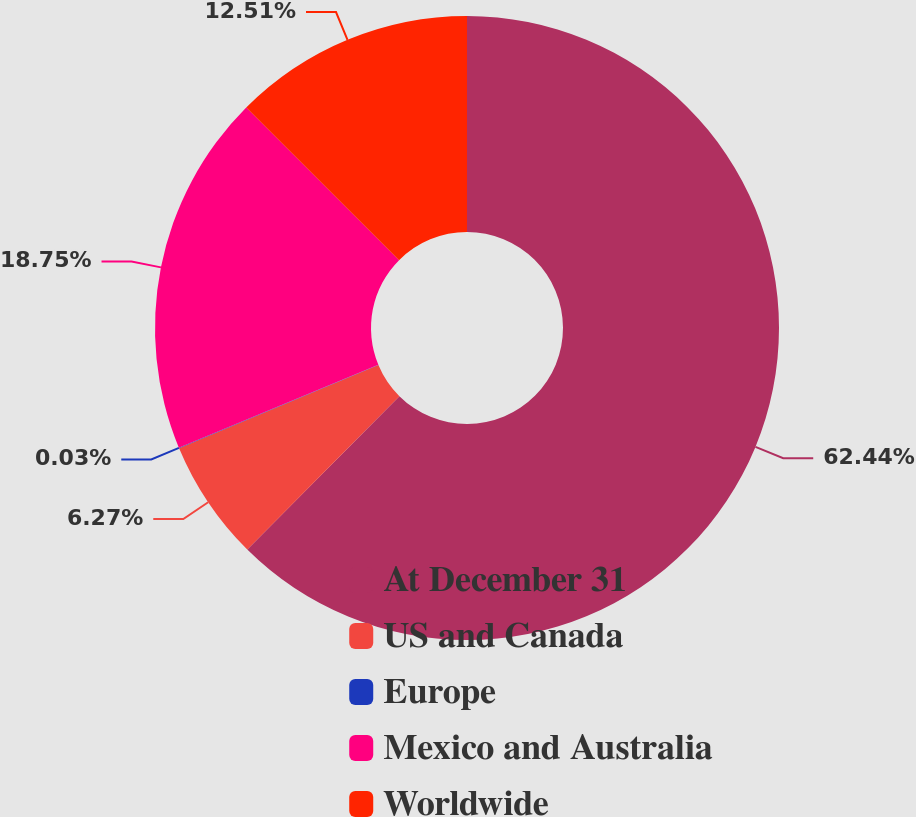<chart> <loc_0><loc_0><loc_500><loc_500><pie_chart><fcel>At December 31<fcel>US and Canada<fcel>Europe<fcel>Mexico and Australia<fcel>Worldwide<nl><fcel>62.43%<fcel>6.27%<fcel>0.03%<fcel>18.75%<fcel>12.51%<nl></chart> 